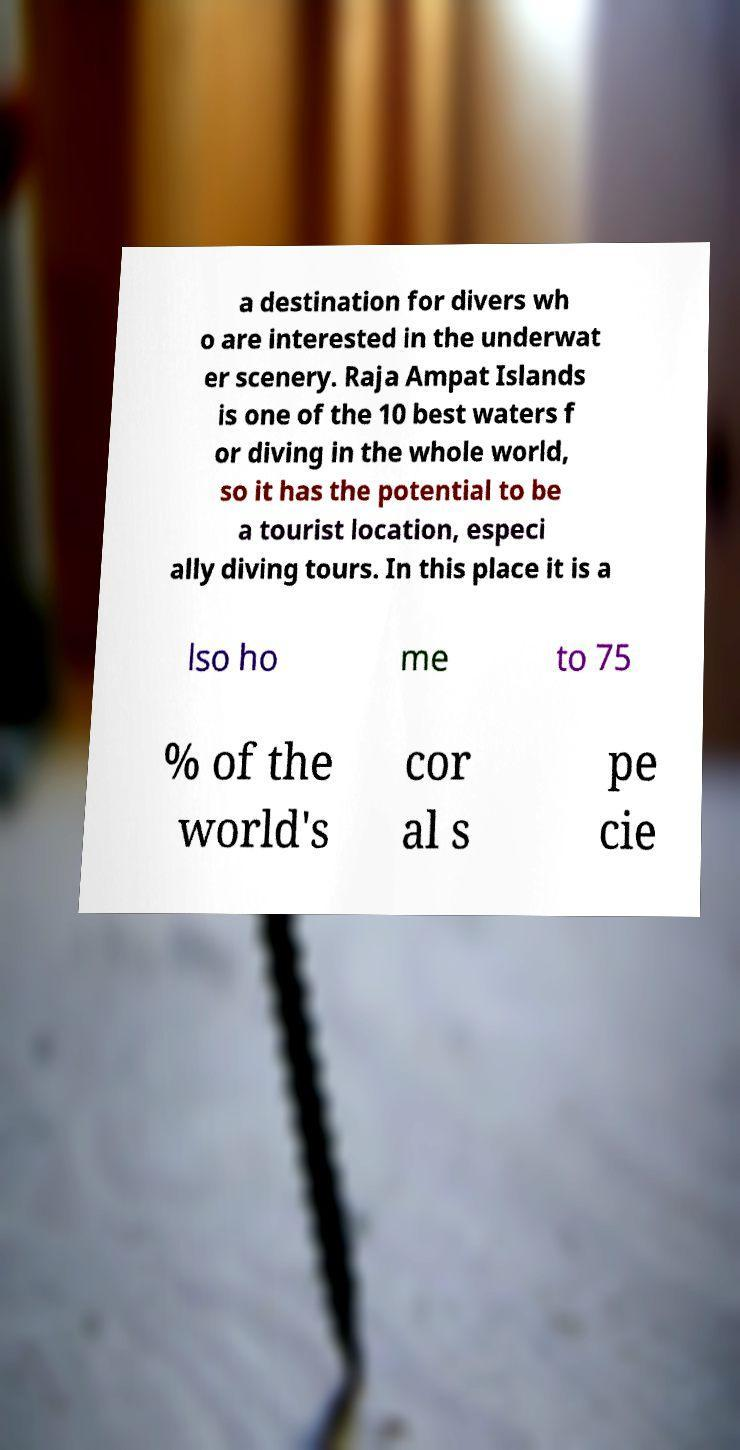For documentation purposes, I need the text within this image transcribed. Could you provide that? a destination for divers wh o are interested in the underwat er scenery. Raja Ampat Islands is one of the 10 best waters f or diving in the whole world, so it has the potential to be a tourist location, especi ally diving tours. In this place it is a lso ho me to 75 % of the world's cor al s pe cie 